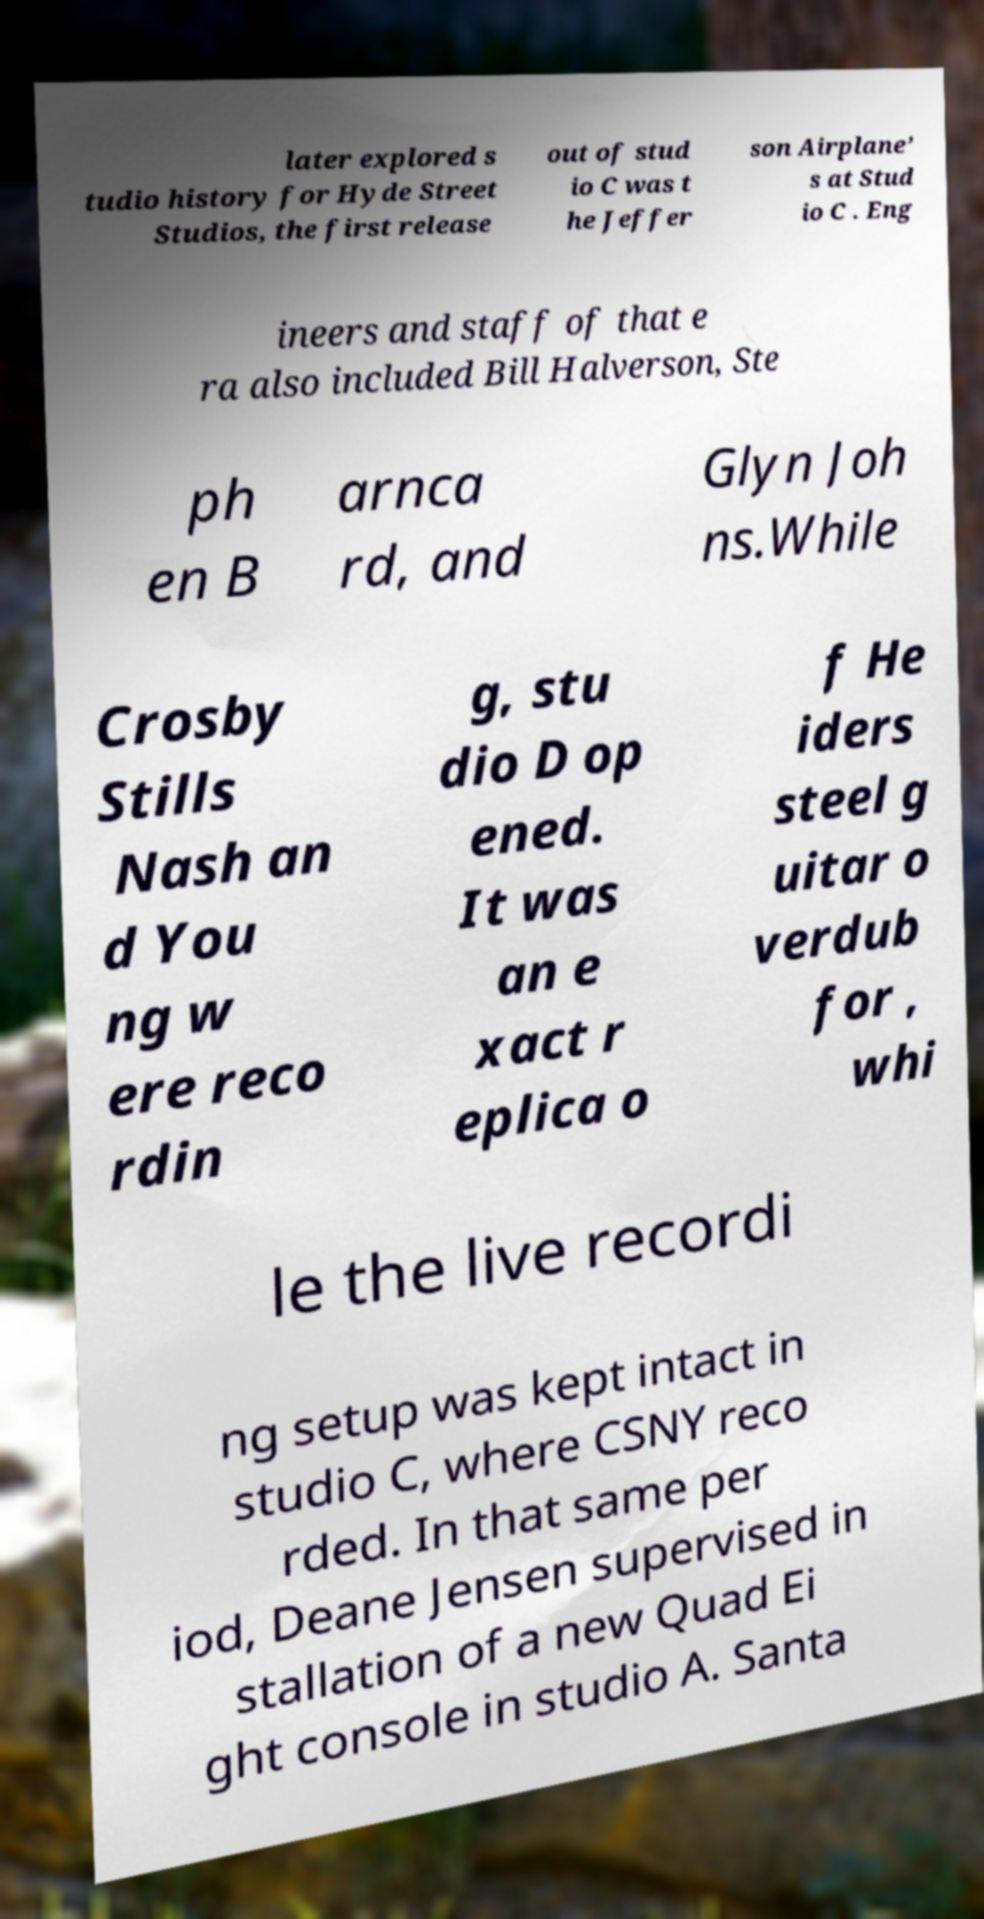There's text embedded in this image that I need extracted. Can you transcribe it verbatim? later explored s tudio history for Hyde Street Studios, the first release out of stud io C was t he Jeffer son Airplane’ s at Stud io C . Eng ineers and staff of that e ra also included Bill Halverson, Ste ph en B arnca rd, and Glyn Joh ns.While Crosby Stills Nash an d You ng w ere reco rdin g, stu dio D op ened. It was an e xact r eplica o f He iders steel g uitar o verdub for , whi le the live recordi ng setup was kept intact in studio C, where CSNY reco rded. In that same per iod, Deane Jensen supervised in stallation of a new Quad Ei ght console in studio A. Santa 